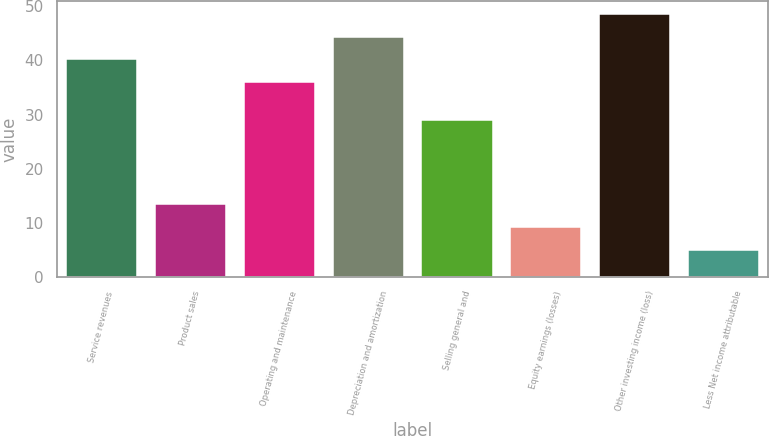Convert chart to OTSL. <chart><loc_0><loc_0><loc_500><loc_500><bar_chart><fcel>Service revenues<fcel>Product sales<fcel>Operating and maintenance<fcel>Depreciation and amortization<fcel>Selling general and<fcel>Equity earnings (losses)<fcel>Other investing income (loss)<fcel>Less Net income attributable<nl><fcel>40.2<fcel>13.4<fcel>36<fcel>44.4<fcel>29<fcel>9.2<fcel>48.6<fcel>5<nl></chart> 